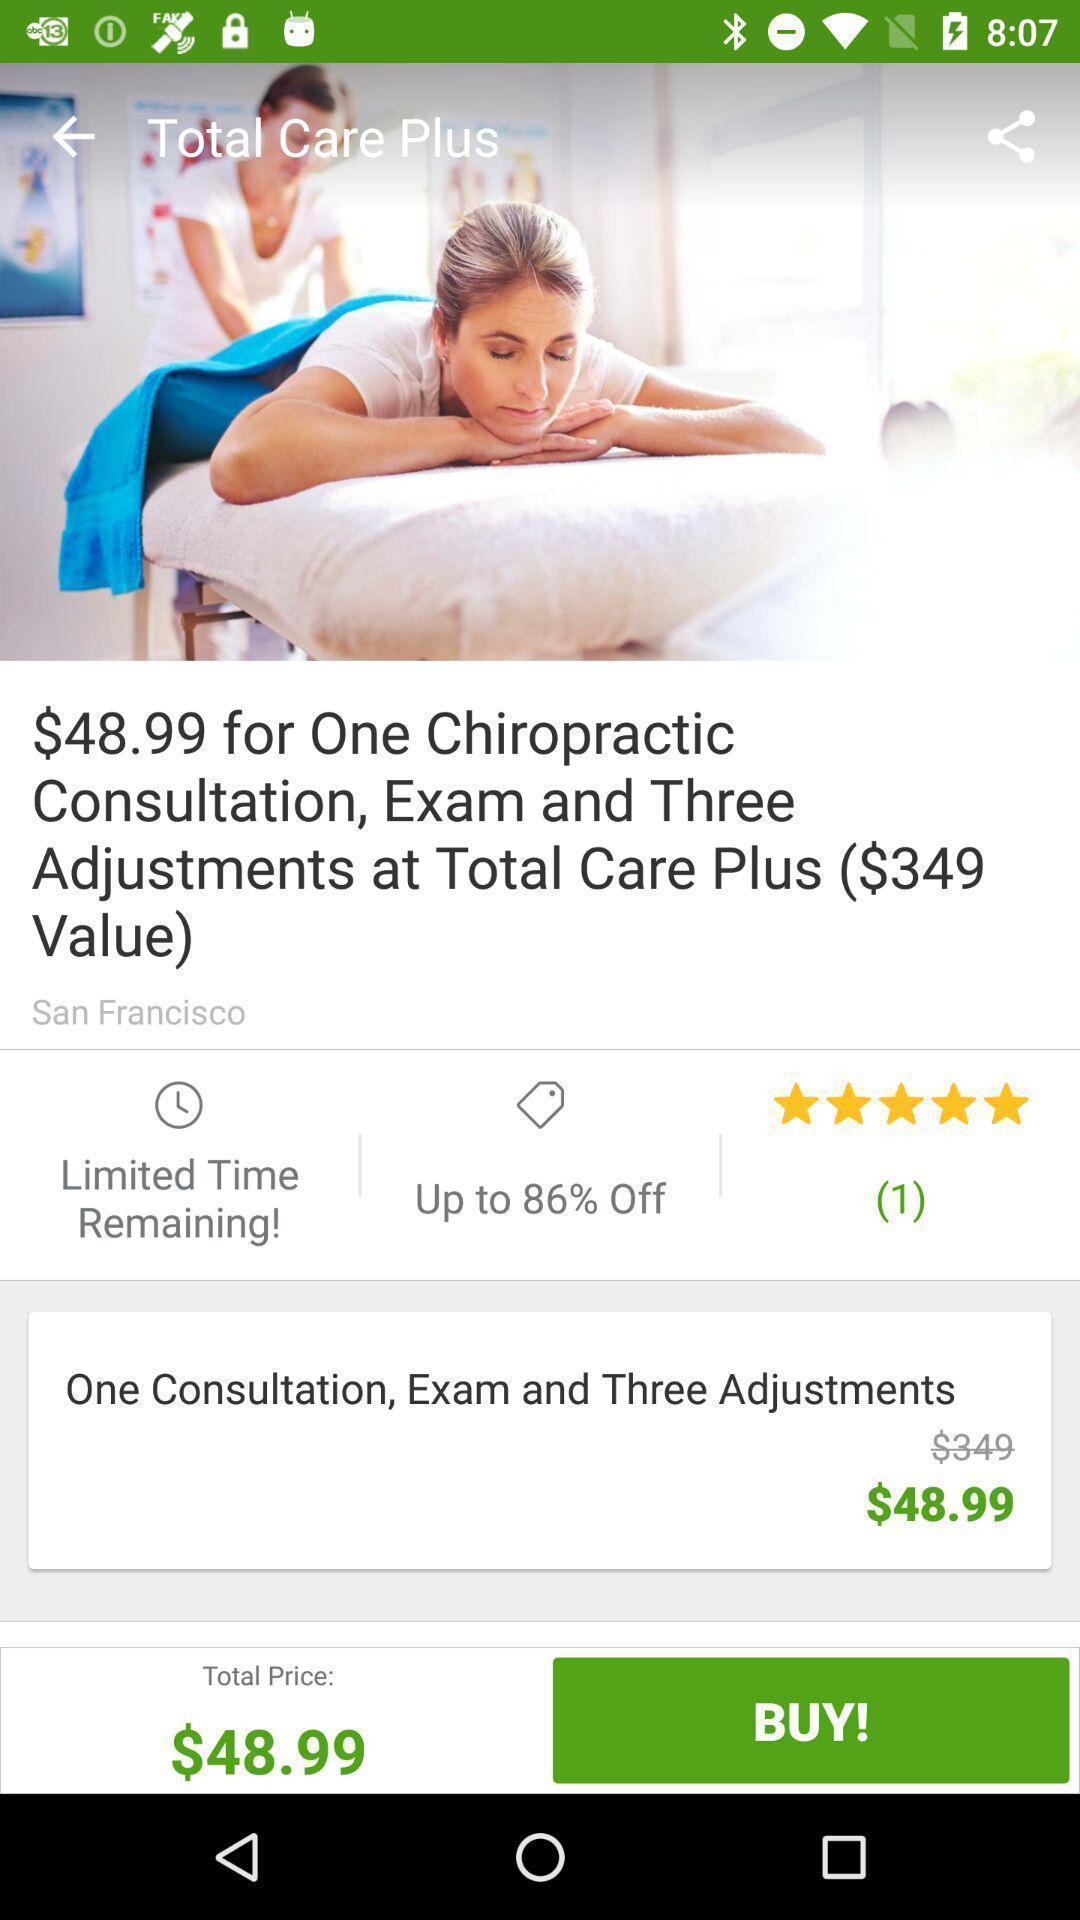Explain the elements present in this screenshot. Total care of heath in health app. 